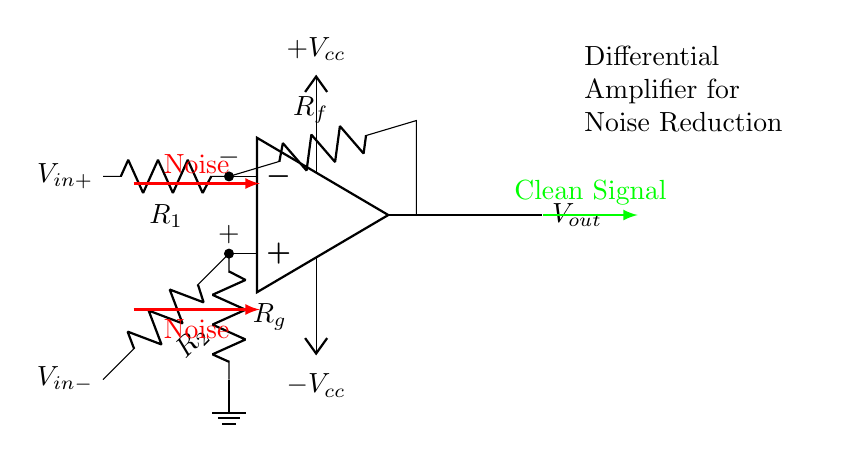What type of amplifier is shown in the diagram? The diagram represents a differential amplifier, which is indicated by the two input voltages and the operational amplifier symbol.
Answer: Differential amplifier What are the input voltages in the circuit? The input voltages are labeled as V sub in plus and V sub in minus, which are connected to the respective terminals of the operational amplifier.
Answer: V in plus, V in minus Which component is used for feedback in the circuit? The feedback resistor connected from the output to the inverting terminal is labeled R sub f, indicating its role in controlling the gain of the amplifier.
Answer: R f What is the function of the red arrows in the diagram? The red arrows illustrate noise signals that are present at both input terminals and demonstrate how differential amplifiers can help cancel this noise.
Answer: Noise cancellation How does this amplifier improve signal quality? By using the differential inputs, the amplifier subtracts the common noise from the signals, enhancing the clean output signal while reducing interference.
Answer: Noise reduction What is the output voltage of the amplifier labeled as? The output voltage is labeled as V sub out, which indicates the processed signal from the differential amplifier.
Answer: V out 